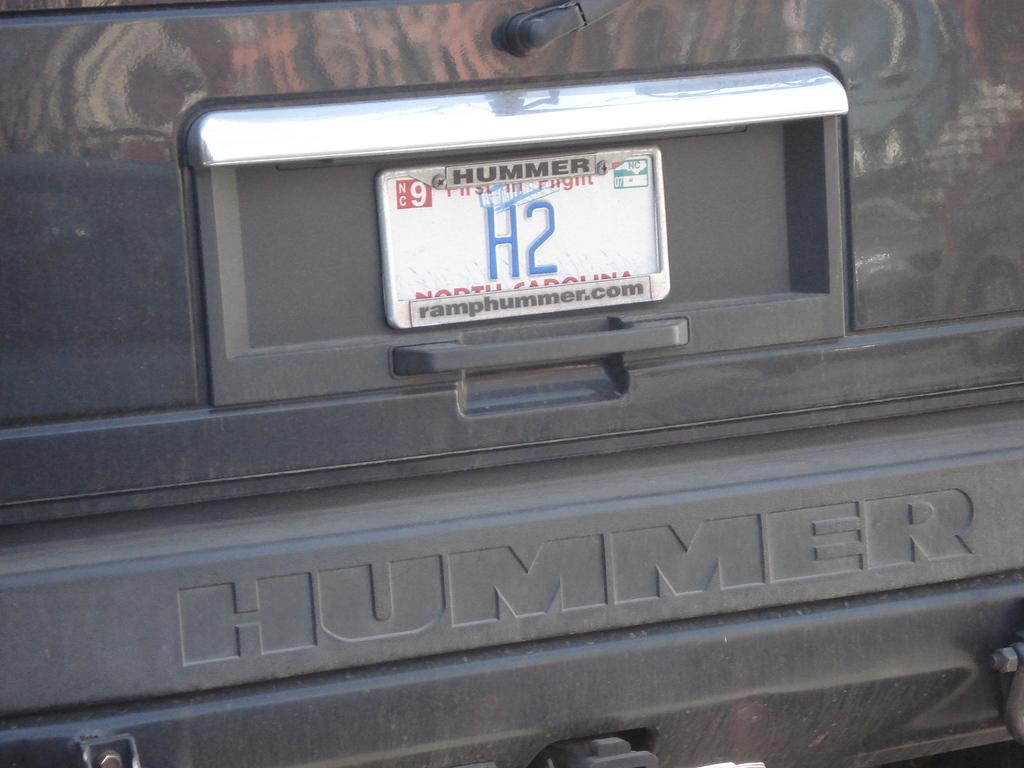<image>
Relay a brief, clear account of the picture shown. A dark grey Hummer with a North Carolina tag that reads H2. 